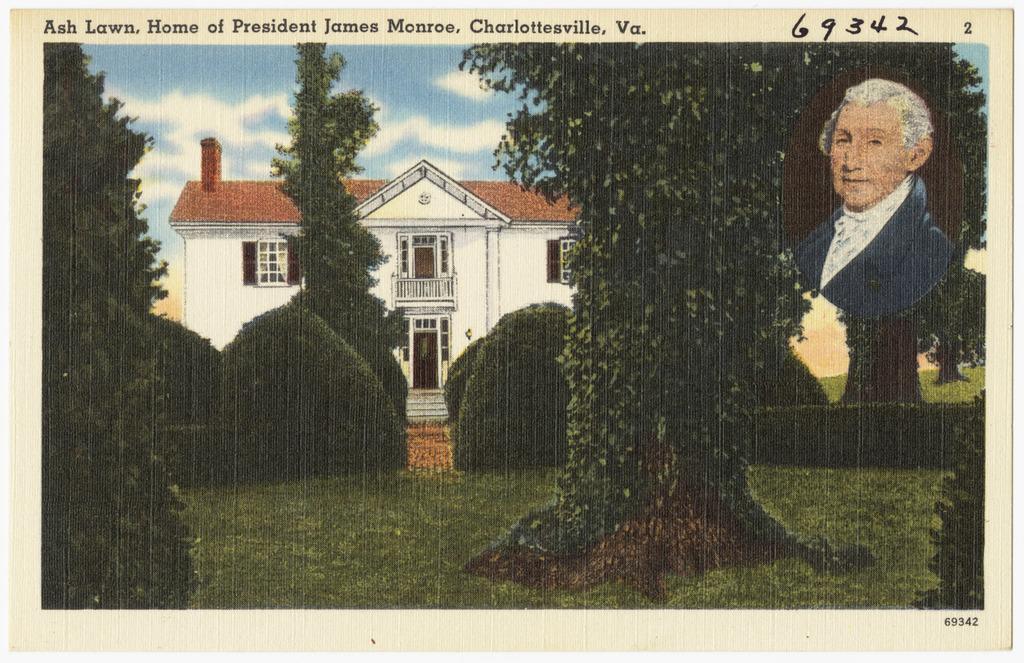Can you describe this image briefly? In the image we can see the poster, in it we can see grass, plants and trees. We can even see the building and these are the windows of the building. Here we can see a cloudy sky and we can see a photo of a person. 